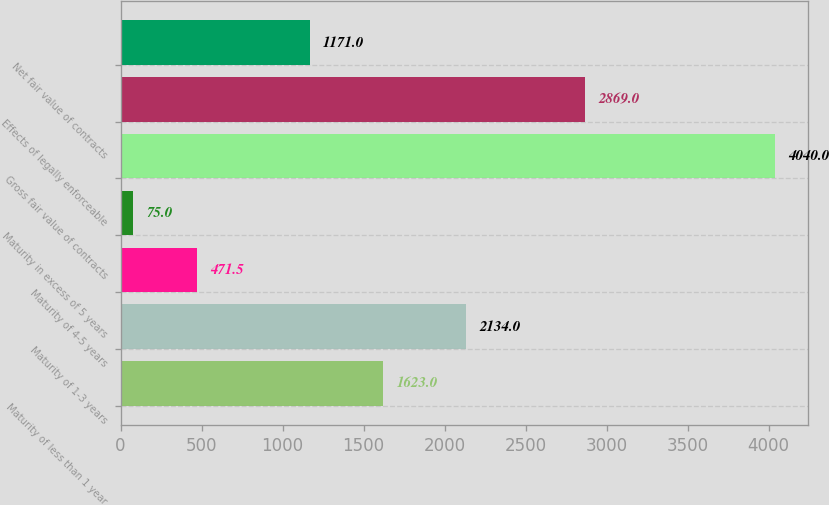<chart> <loc_0><loc_0><loc_500><loc_500><bar_chart><fcel>Maturity of less than 1 year<fcel>Maturity of 1-3 years<fcel>Maturity of 4-5 years<fcel>Maturity in excess of 5 years<fcel>Gross fair value of contracts<fcel>Effects of legally enforceable<fcel>Net fair value of contracts<nl><fcel>1623<fcel>2134<fcel>471.5<fcel>75<fcel>4040<fcel>2869<fcel>1171<nl></chart> 